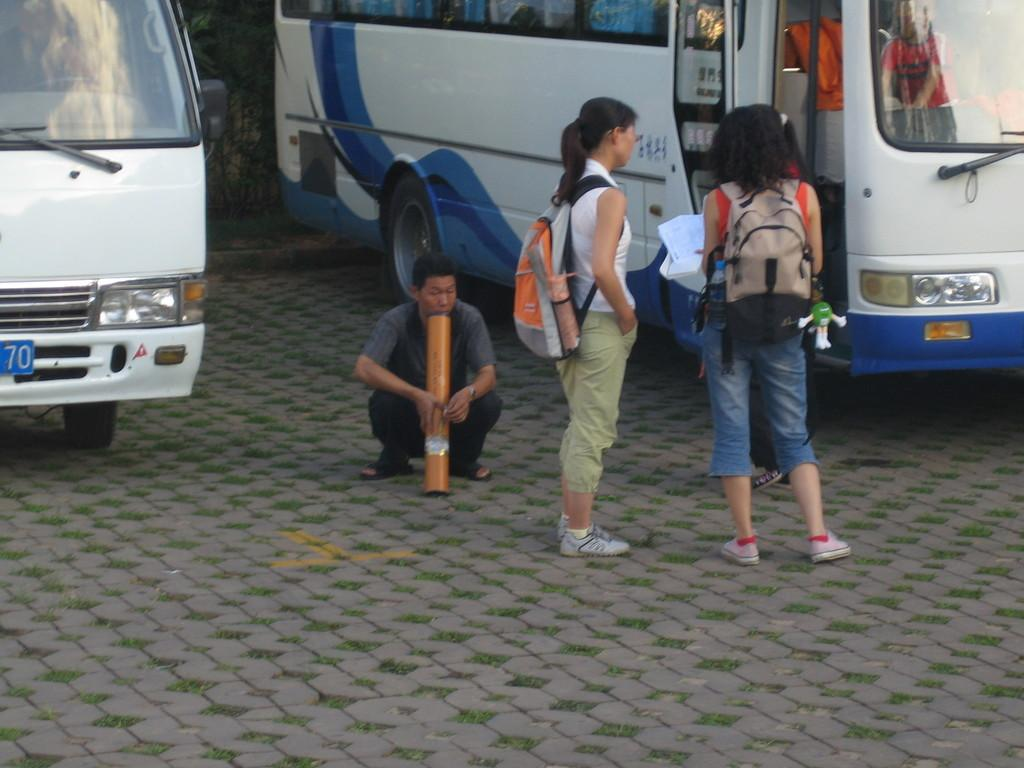What is the main focus of the image? The main focus of the image is the people in the center. What can be seen in the background of the image? There are buses and a tree in the background of the image. What type of muscle is being exercised by the people in the image? There is no indication of any exercise or muscle activity in the image; it simply shows people in the center. 